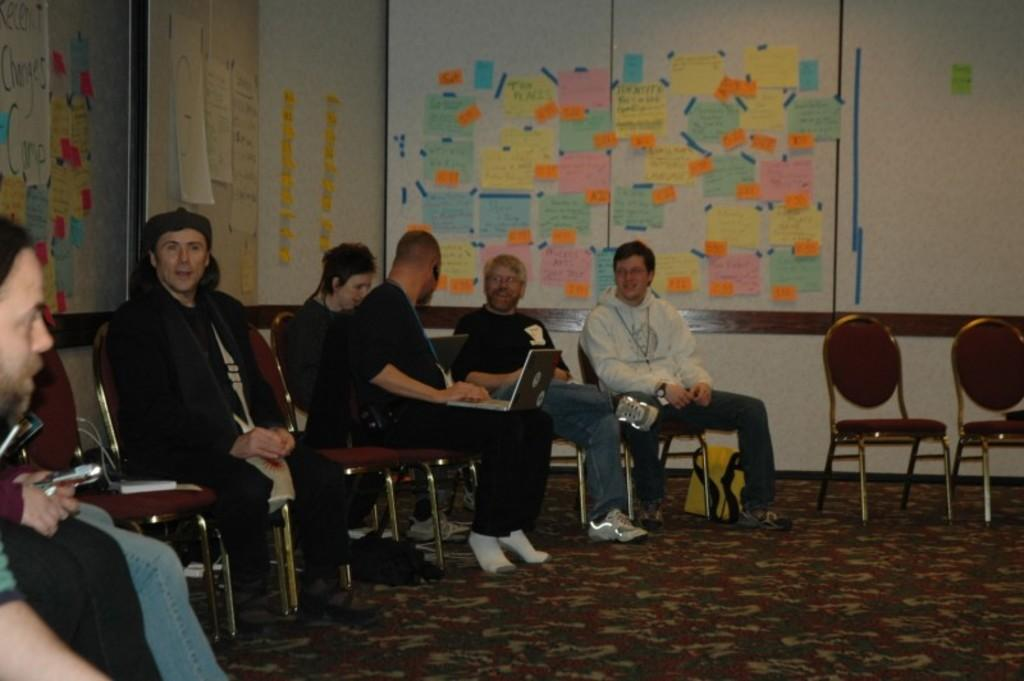What are the people in the image doing? The people in the image are sitting in chairs. What is one person specifically doing? One person is operating a laptop. What can be seen in the background of the image? There is a wall in the background of the image. What is on the wall in the image? There are papers pasted on the wall. What type of tooth is visible in the image? There is no tooth present in the image. What theory is being discussed by the people in the image? The image does not provide any information about a theory being discussed. 